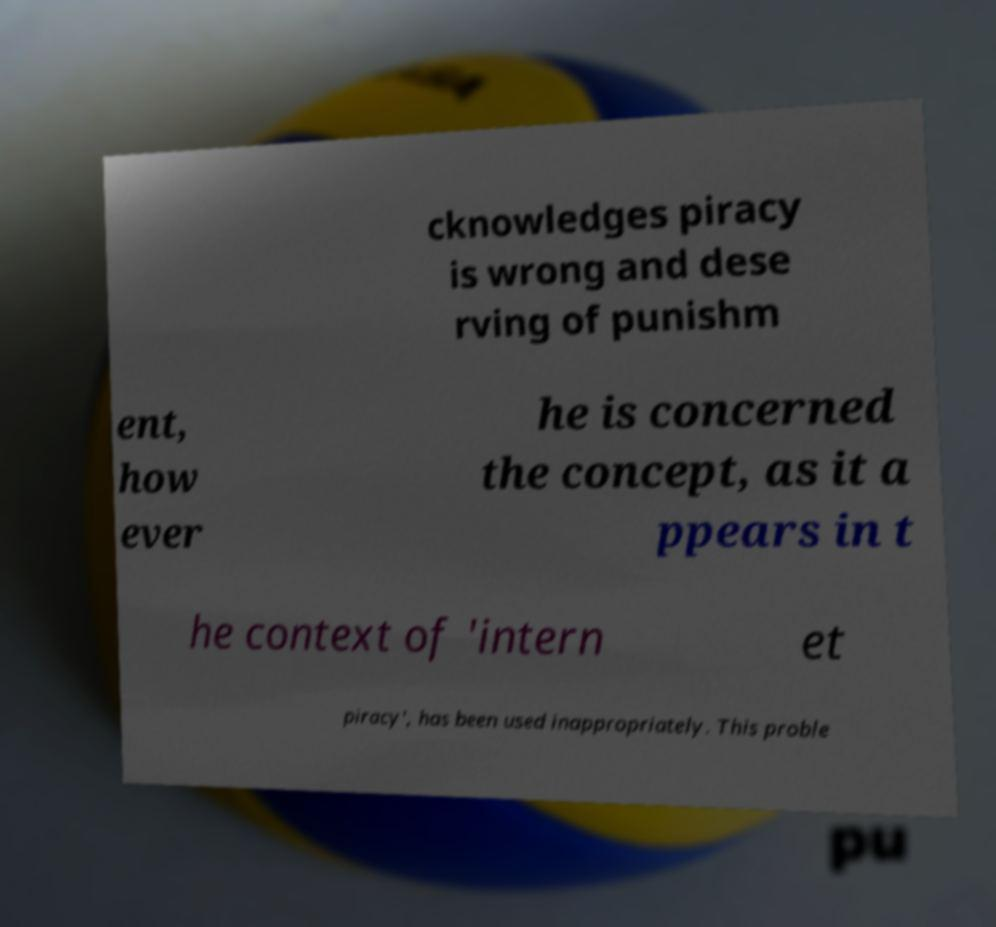Can you read and provide the text displayed in the image?This photo seems to have some interesting text. Can you extract and type it out for me? cknowledges piracy is wrong and dese rving of punishm ent, how ever he is concerned the concept, as it a ppears in t he context of 'intern et piracy', has been used inappropriately. This proble 